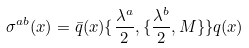<formula> <loc_0><loc_0><loc_500><loc_500>\sigma ^ { a b } ( x ) = \bar { q } ( x ) \{ \frac { \lambda ^ { a } } { 2 } , \{ \frac { \lambda ^ { b } } { 2 } , M \} \} q ( x )</formula> 